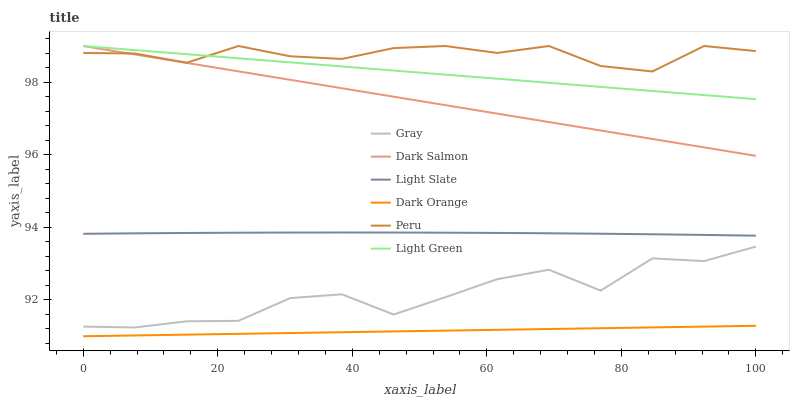Does Dark Orange have the minimum area under the curve?
Answer yes or no. Yes. Does Peru have the maximum area under the curve?
Answer yes or no. Yes. Does Peru have the minimum area under the curve?
Answer yes or no. No. Does Dark Orange have the maximum area under the curve?
Answer yes or no. No. Is Light Green the smoothest?
Answer yes or no. Yes. Is Gray the roughest?
Answer yes or no. Yes. Is Peru the smoothest?
Answer yes or no. No. Is Peru the roughest?
Answer yes or no. No. Does Peru have the lowest value?
Answer yes or no. No. Does Dark Orange have the highest value?
Answer yes or no. No. Is Dark Orange less than Gray?
Answer yes or no. Yes. Is Light Slate greater than Dark Orange?
Answer yes or no. Yes. Does Dark Orange intersect Gray?
Answer yes or no. No. 